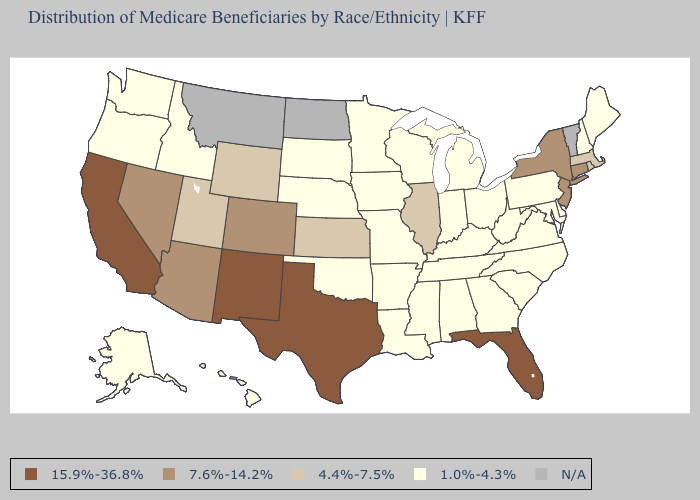Does Rhode Island have the highest value in the Northeast?
Keep it brief. No. What is the value of New York?
Keep it brief. 7.6%-14.2%. What is the value of South Dakota?
Answer briefly. 1.0%-4.3%. What is the highest value in states that border Pennsylvania?
Answer briefly. 7.6%-14.2%. What is the highest value in the USA?
Answer briefly. 15.9%-36.8%. What is the value of Connecticut?
Concise answer only. 7.6%-14.2%. Does Texas have the highest value in the South?
Answer briefly. Yes. What is the value of Wyoming?
Give a very brief answer. 4.4%-7.5%. Among the states that border Indiana , does Illinois have the highest value?
Write a very short answer. Yes. Among the states that border Pennsylvania , does New York have the highest value?
Keep it brief. Yes. What is the value of Idaho?
Give a very brief answer. 1.0%-4.3%. What is the value of Vermont?
Short answer required. N/A. Name the states that have a value in the range 4.4%-7.5%?
Give a very brief answer. Illinois, Kansas, Massachusetts, Rhode Island, Utah, Wyoming. 